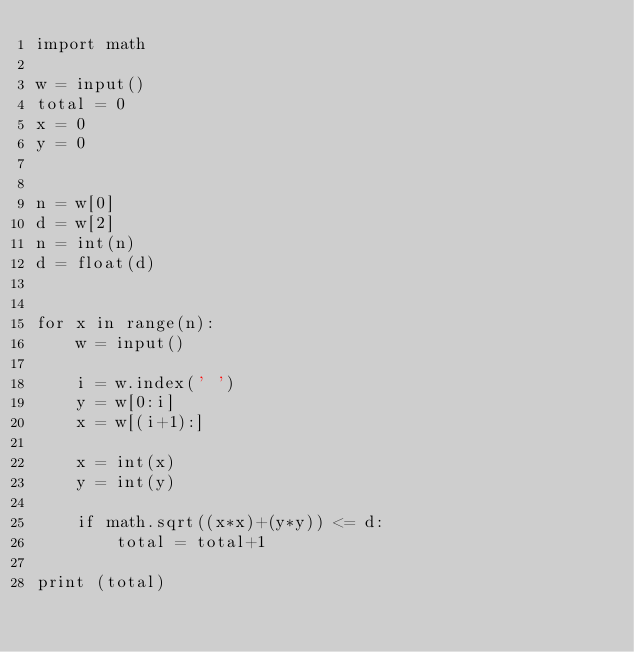<code> <loc_0><loc_0><loc_500><loc_500><_Python_>import math

w = input()
total = 0
x = 0
y = 0


n = w[0]
d = w[2]
n = int(n)
d = float(d)


for x in range(n):
    w = input()

    i = w.index(' ')
    y = w[0:i]
    x = w[(i+1):]

    x = int(x)
    y = int(y)

    if math.sqrt((x*x)+(y*y)) <= d:
        total = total+1

print (total)</code> 